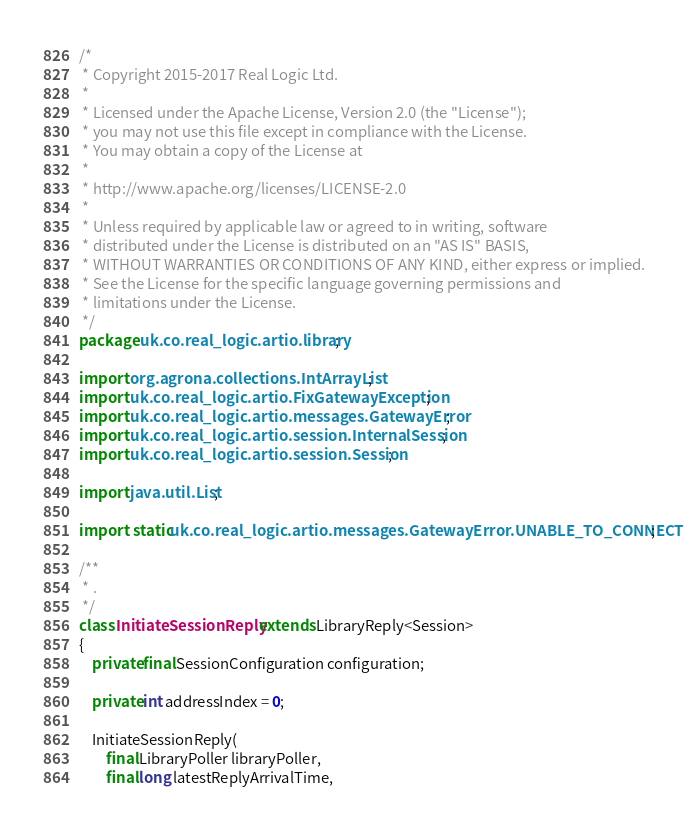<code> <loc_0><loc_0><loc_500><loc_500><_Java_>/*
 * Copyright 2015-2017 Real Logic Ltd.
 *
 * Licensed under the Apache License, Version 2.0 (the "License");
 * you may not use this file except in compliance with the License.
 * You may obtain a copy of the License at
 *
 * http://www.apache.org/licenses/LICENSE-2.0
 *
 * Unless required by applicable law or agreed to in writing, software
 * distributed under the License is distributed on an "AS IS" BASIS,
 * WITHOUT WARRANTIES OR CONDITIONS OF ANY KIND, either express or implied.
 * See the License for the specific language governing permissions and
 * limitations under the License.
 */
package uk.co.real_logic.artio.library;

import org.agrona.collections.IntArrayList;
import uk.co.real_logic.artio.FixGatewayException;
import uk.co.real_logic.artio.messages.GatewayError;
import uk.co.real_logic.artio.session.InternalSession;
import uk.co.real_logic.artio.session.Session;

import java.util.List;

import static uk.co.real_logic.artio.messages.GatewayError.UNABLE_TO_CONNECT;

/**
 * .
 */
class InitiateSessionReply extends LibraryReply<Session>
{
    private final SessionConfiguration configuration;

    private int addressIndex = 0;

    InitiateSessionReply(
        final LibraryPoller libraryPoller,
        final long latestReplyArrivalTime,</code> 